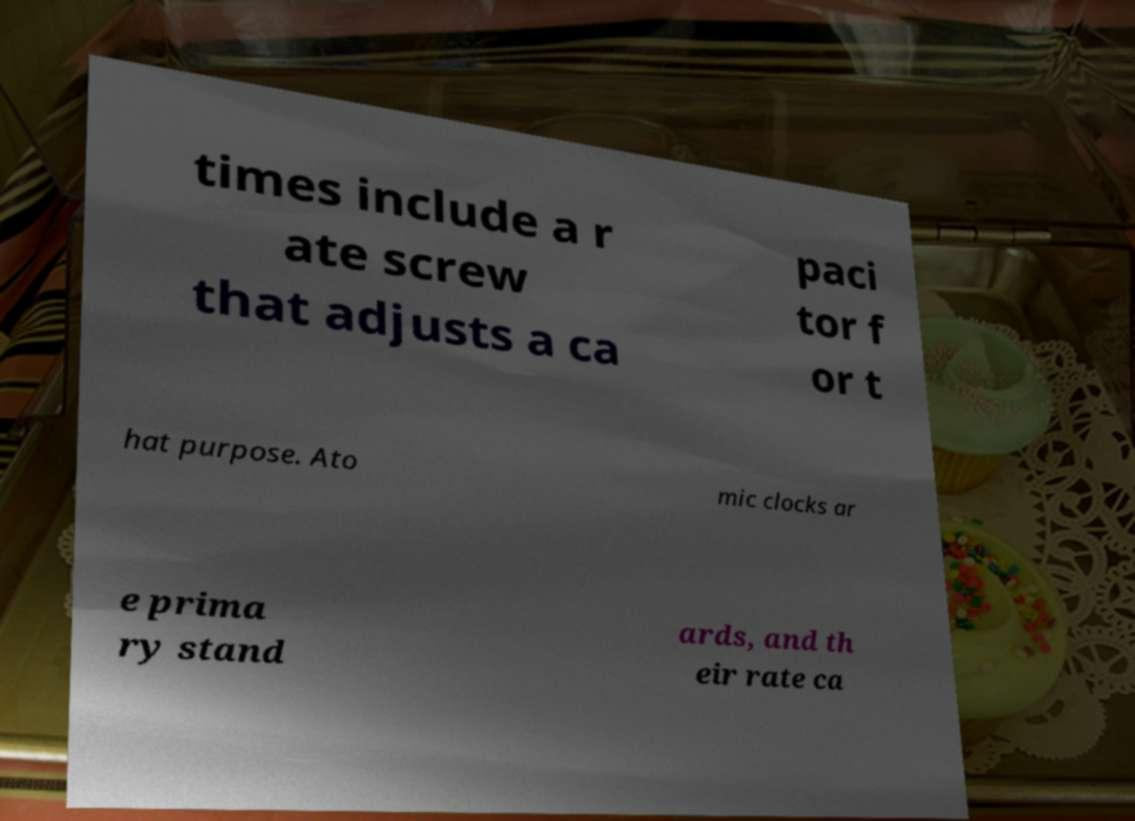For documentation purposes, I need the text within this image transcribed. Could you provide that? times include a r ate screw that adjusts a ca paci tor f or t hat purpose. Ato mic clocks ar e prima ry stand ards, and th eir rate ca 